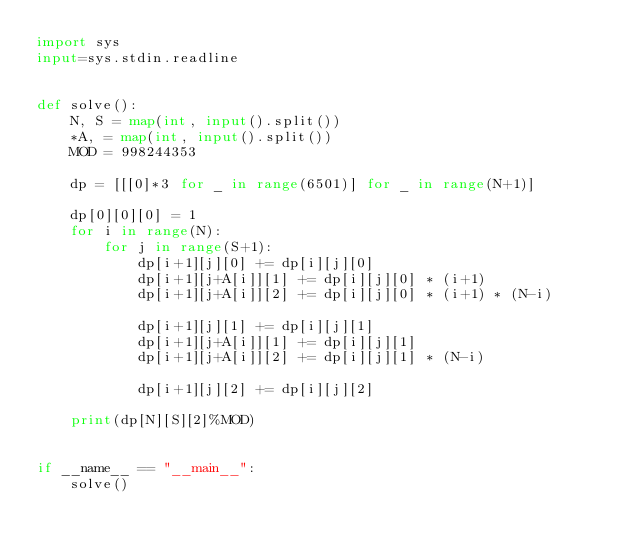Convert code to text. <code><loc_0><loc_0><loc_500><loc_500><_Python_>import sys
input=sys.stdin.readline


def solve():
    N, S = map(int, input().split())
    *A, = map(int, input().split())
    MOD = 998244353

    dp = [[[0]*3 for _ in range(6501)] for _ in range(N+1)]

    dp[0][0][0] = 1
    for i in range(N):
        for j in range(S+1):
            dp[i+1][j][0] += dp[i][j][0]
            dp[i+1][j+A[i]][1] += dp[i][j][0] * (i+1)
            dp[i+1][j+A[i]][2] += dp[i][j][0] * (i+1) * (N-i)

            dp[i+1][j][1] += dp[i][j][1]
            dp[i+1][j+A[i]][1] += dp[i][j][1]
            dp[i+1][j+A[i]][2] += dp[i][j][1] * (N-i)

            dp[i+1][j][2] += dp[i][j][2]

    print(dp[N][S][2]%MOD)


if __name__ == "__main__":
    solve()
</code> 